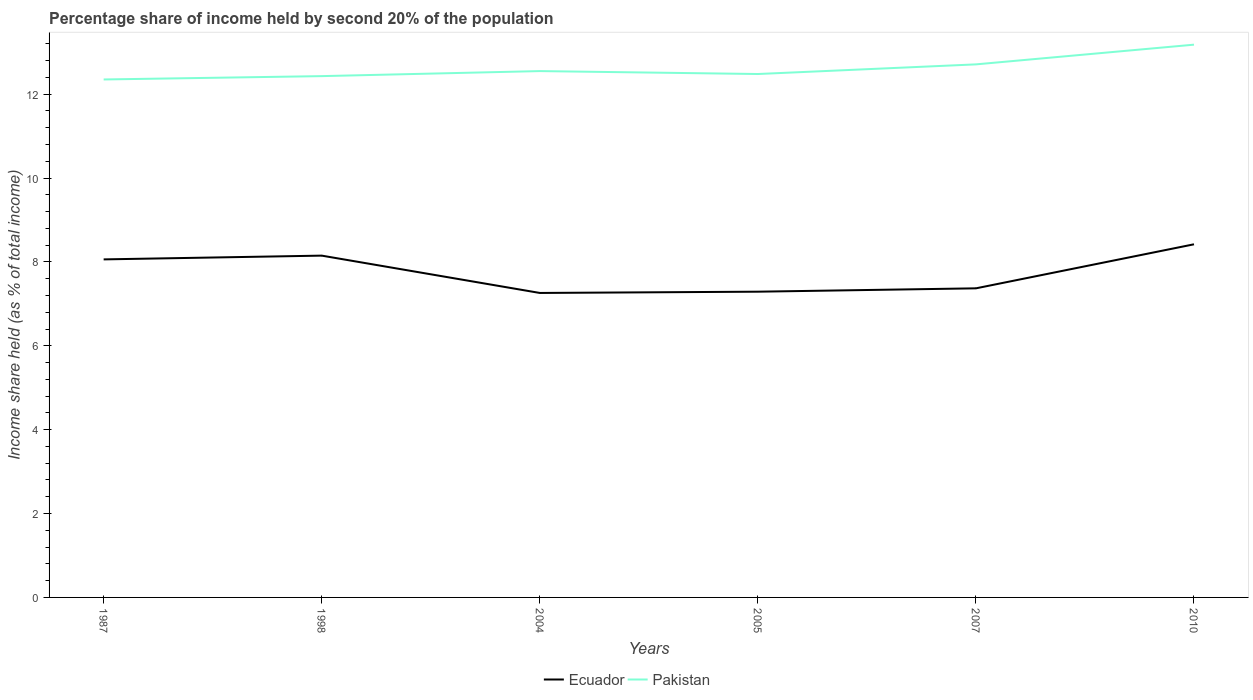Does the line corresponding to Ecuador intersect with the line corresponding to Pakistan?
Your response must be concise. No. Across all years, what is the maximum share of income held by second 20% of the population in Pakistan?
Offer a terse response. 12.35. In which year was the share of income held by second 20% of the population in Pakistan maximum?
Your answer should be very brief. 1987. What is the total share of income held by second 20% of the population in Pakistan in the graph?
Give a very brief answer. -0.16. What is the difference between the highest and the second highest share of income held by second 20% of the population in Pakistan?
Give a very brief answer. 0.83. What is the difference between the highest and the lowest share of income held by second 20% of the population in Pakistan?
Ensure brevity in your answer.  2. How many lines are there?
Provide a succinct answer. 2. What is the difference between two consecutive major ticks on the Y-axis?
Offer a terse response. 2. Does the graph contain any zero values?
Make the answer very short. No. Does the graph contain grids?
Your response must be concise. No. Where does the legend appear in the graph?
Your response must be concise. Bottom center. How many legend labels are there?
Offer a terse response. 2. What is the title of the graph?
Offer a terse response. Percentage share of income held by second 20% of the population. Does "Faeroe Islands" appear as one of the legend labels in the graph?
Offer a very short reply. No. What is the label or title of the Y-axis?
Offer a very short reply. Income share held (as % of total income). What is the Income share held (as % of total income) in Ecuador in 1987?
Keep it short and to the point. 8.06. What is the Income share held (as % of total income) in Pakistan in 1987?
Your answer should be compact. 12.35. What is the Income share held (as % of total income) in Ecuador in 1998?
Your response must be concise. 8.15. What is the Income share held (as % of total income) in Pakistan in 1998?
Your answer should be compact. 12.43. What is the Income share held (as % of total income) in Ecuador in 2004?
Offer a very short reply. 7.26. What is the Income share held (as % of total income) in Pakistan in 2004?
Give a very brief answer. 12.55. What is the Income share held (as % of total income) of Ecuador in 2005?
Your answer should be very brief. 7.29. What is the Income share held (as % of total income) of Pakistan in 2005?
Give a very brief answer. 12.48. What is the Income share held (as % of total income) in Ecuador in 2007?
Give a very brief answer. 7.37. What is the Income share held (as % of total income) of Pakistan in 2007?
Offer a very short reply. 12.71. What is the Income share held (as % of total income) in Ecuador in 2010?
Ensure brevity in your answer.  8.42. What is the Income share held (as % of total income) in Pakistan in 2010?
Your answer should be very brief. 13.18. Across all years, what is the maximum Income share held (as % of total income) of Ecuador?
Provide a short and direct response. 8.42. Across all years, what is the maximum Income share held (as % of total income) of Pakistan?
Your response must be concise. 13.18. Across all years, what is the minimum Income share held (as % of total income) in Ecuador?
Offer a terse response. 7.26. Across all years, what is the minimum Income share held (as % of total income) in Pakistan?
Provide a short and direct response. 12.35. What is the total Income share held (as % of total income) in Ecuador in the graph?
Your answer should be compact. 46.55. What is the total Income share held (as % of total income) of Pakistan in the graph?
Provide a short and direct response. 75.7. What is the difference between the Income share held (as % of total income) in Ecuador in 1987 and that in 1998?
Ensure brevity in your answer.  -0.09. What is the difference between the Income share held (as % of total income) of Pakistan in 1987 and that in 1998?
Offer a terse response. -0.08. What is the difference between the Income share held (as % of total income) of Ecuador in 1987 and that in 2005?
Make the answer very short. 0.77. What is the difference between the Income share held (as % of total income) of Pakistan in 1987 and that in 2005?
Give a very brief answer. -0.13. What is the difference between the Income share held (as % of total income) in Ecuador in 1987 and that in 2007?
Your response must be concise. 0.69. What is the difference between the Income share held (as % of total income) of Pakistan in 1987 and that in 2007?
Keep it short and to the point. -0.36. What is the difference between the Income share held (as % of total income) in Ecuador in 1987 and that in 2010?
Provide a succinct answer. -0.36. What is the difference between the Income share held (as % of total income) in Pakistan in 1987 and that in 2010?
Your answer should be compact. -0.83. What is the difference between the Income share held (as % of total income) in Ecuador in 1998 and that in 2004?
Offer a very short reply. 0.89. What is the difference between the Income share held (as % of total income) in Pakistan in 1998 and that in 2004?
Your answer should be compact. -0.12. What is the difference between the Income share held (as % of total income) in Ecuador in 1998 and that in 2005?
Your answer should be very brief. 0.86. What is the difference between the Income share held (as % of total income) in Ecuador in 1998 and that in 2007?
Provide a short and direct response. 0.78. What is the difference between the Income share held (as % of total income) of Pakistan in 1998 and that in 2007?
Your answer should be very brief. -0.28. What is the difference between the Income share held (as % of total income) in Ecuador in 1998 and that in 2010?
Your answer should be compact. -0.27. What is the difference between the Income share held (as % of total income) in Pakistan in 1998 and that in 2010?
Give a very brief answer. -0.75. What is the difference between the Income share held (as % of total income) in Ecuador in 2004 and that in 2005?
Provide a short and direct response. -0.03. What is the difference between the Income share held (as % of total income) of Pakistan in 2004 and that in 2005?
Your answer should be very brief. 0.07. What is the difference between the Income share held (as % of total income) in Ecuador in 2004 and that in 2007?
Give a very brief answer. -0.11. What is the difference between the Income share held (as % of total income) of Pakistan in 2004 and that in 2007?
Give a very brief answer. -0.16. What is the difference between the Income share held (as % of total income) in Ecuador in 2004 and that in 2010?
Your answer should be very brief. -1.16. What is the difference between the Income share held (as % of total income) of Pakistan in 2004 and that in 2010?
Provide a succinct answer. -0.63. What is the difference between the Income share held (as % of total income) of Ecuador in 2005 and that in 2007?
Your answer should be very brief. -0.08. What is the difference between the Income share held (as % of total income) of Pakistan in 2005 and that in 2007?
Make the answer very short. -0.23. What is the difference between the Income share held (as % of total income) of Ecuador in 2005 and that in 2010?
Provide a short and direct response. -1.13. What is the difference between the Income share held (as % of total income) in Pakistan in 2005 and that in 2010?
Provide a succinct answer. -0.7. What is the difference between the Income share held (as % of total income) in Ecuador in 2007 and that in 2010?
Provide a short and direct response. -1.05. What is the difference between the Income share held (as % of total income) of Pakistan in 2007 and that in 2010?
Give a very brief answer. -0.47. What is the difference between the Income share held (as % of total income) of Ecuador in 1987 and the Income share held (as % of total income) of Pakistan in 1998?
Your answer should be very brief. -4.37. What is the difference between the Income share held (as % of total income) of Ecuador in 1987 and the Income share held (as % of total income) of Pakistan in 2004?
Your response must be concise. -4.49. What is the difference between the Income share held (as % of total income) of Ecuador in 1987 and the Income share held (as % of total income) of Pakistan in 2005?
Provide a short and direct response. -4.42. What is the difference between the Income share held (as % of total income) in Ecuador in 1987 and the Income share held (as % of total income) in Pakistan in 2007?
Offer a very short reply. -4.65. What is the difference between the Income share held (as % of total income) of Ecuador in 1987 and the Income share held (as % of total income) of Pakistan in 2010?
Your answer should be very brief. -5.12. What is the difference between the Income share held (as % of total income) of Ecuador in 1998 and the Income share held (as % of total income) of Pakistan in 2005?
Your answer should be very brief. -4.33. What is the difference between the Income share held (as % of total income) in Ecuador in 1998 and the Income share held (as % of total income) in Pakistan in 2007?
Your answer should be very brief. -4.56. What is the difference between the Income share held (as % of total income) in Ecuador in 1998 and the Income share held (as % of total income) in Pakistan in 2010?
Your answer should be compact. -5.03. What is the difference between the Income share held (as % of total income) of Ecuador in 2004 and the Income share held (as % of total income) of Pakistan in 2005?
Offer a very short reply. -5.22. What is the difference between the Income share held (as % of total income) of Ecuador in 2004 and the Income share held (as % of total income) of Pakistan in 2007?
Provide a succinct answer. -5.45. What is the difference between the Income share held (as % of total income) in Ecuador in 2004 and the Income share held (as % of total income) in Pakistan in 2010?
Offer a very short reply. -5.92. What is the difference between the Income share held (as % of total income) of Ecuador in 2005 and the Income share held (as % of total income) of Pakistan in 2007?
Your answer should be compact. -5.42. What is the difference between the Income share held (as % of total income) in Ecuador in 2005 and the Income share held (as % of total income) in Pakistan in 2010?
Offer a terse response. -5.89. What is the difference between the Income share held (as % of total income) of Ecuador in 2007 and the Income share held (as % of total income) of Pakistan in 2010?
Offer a very short reply. -5.81. What is the average Income share held (as % of total income) in Ecuador per year?
Keep it short and to the point. 7.76. What is the average Income share held (as % of total income) of Pakistan per year?
Your answer should be compact. 12.62. In the year 1987, what is the difference between the Income share held (as % of total income) of Ecuador and Income share held (as % of total income) of Pakistan?
Your answer should be compact. -4.29. In the year 1998, what is the difference between the Income share held (as % of total income) in Ecuador and Income share held (as % of total income) in Pakistan?
Make the answer very short. -4.28. In the year 2004, what is the difference between the Income share held (as % of total income) in Ecuador and Income share held (as % of total income) in Pakistan?
Provide a short and direct response. -5.29. In the year 2005, what is the difference between the Income share held (as % of total income) in Ecuador and Income share held (as % of total income) in Pakistan?
Keep it short and to the point. -5.19. In the year 2007, what is the difference between the Income share held (as % of total income) of Ecuador and Income share held (as % of total income) of Pakistan?
Offer a very short reply. -5.34. In the year 2010, what is the difference between the Income share held (as % of total income) of Ecuador and Income share held (as % of total income) of Pakistan?
Make the answer very short. -4.76. What is the ratio of the Income share held (as % of total income) in Ecuador in 1987 to that in 2004?
Keep it short and to the point. 1.11. What is the ratio of the Income share held (as % of total income) of Pakistan in 1987 to that in 2004?
Make the answer very short. 0.98. What is the ratio of the Income share held (as % of total income) in Ecuador in 1987 to that in 2005?
Your answer should be compact. 1.11. What is the ratio of the Income share held (as % of total income) in Ecuador in 1987 to that in 2007?
Offer a very short reply. 1.09. What is the ratio of the Income share held (as % of total income) in Pakistan in 1987 to that in 2007?
Your response must be concise. 0.97. What is the ratio of the Income share held (as % of total income) of Ecuador in 1987 to that in 2010?
Your response must be concise. 0.96. What is the ratio of the Income share held (as % of total income) of Pakistan in 1987 to that in 2010?
Provide a short and direct response. 0.94. What is the ratio of the Income share held (as % of total income) in Ecuador in 1998 to that in 2004?
Provide a succinct answer. 1.12. What is the ratio of the Income share held (as % of total income) of Ecuador in 1998 to that in 2005?
Your response must be concise. 1.12. What is the ratio of the Income share held (as % of total income) of Ecuador in 1998 to that in 2007?
Offer a terse response. 1.11. What is the ratio of the Income share held (as % of total income) of Pakistan in 1998 to that in 2007?
Provide a short and direct response. 0.98. What is the ratio of the Income share held (as % of total income) of Ecuador in 1998 to that in 2010?
Your response must be concise. 0.97. What is the ratio of the Income share held (as % of total income) in Pakistan in 1998 to that in 2010?
Offer a terse response. 0.94. What is the ratio of the Income share held (as % of total income) in Ecuador in 2004 to that in 2005?
Offer a very short reply. 1. What is the ratio of the Income share held (as % of total income) in Pakistan in 2004 to that in 2005?
Keep it short and to the point. 1.01. What is the ratio of the Income share held (as % of total income) in Ecuador in 2004 to that in 2007?
Ensure brevity in your answer.  0.99. What is the ratio of the Income share held (as % of total income) of Pakistan in 2004 to that in 2007?
Your answer should be very brief. 0.99. What is the ratio of the Income share held (as % of total income) of Ecuador in 2004 to that in 2010?
Provide a succinct answer. 0.86. What is the ratio of the Income share held (as % of total income) in Pakistan in 2004 to that in 2010?
Make the answer very short. 0.95. What is the ratio of the Income share held (as % of total income) in Pakistan in 2005 to that in 2007?
Offer a very short reply. 0.98. What is the ratio of the Income share held (as % of total income) of Ecuador in 2005 to that in 2010?
Provide a succinct answer. 0.87. What is the ratio of the Income share held (as % of total income) of Pakistan in 2005 to that in 2010?
Your answer should be very brief. 0.95. What is the ratio of the Income share held (as % of total income) of Ecuador in 2007 to that in 2010?
Provide a short and direct response. 0.88. What is the difference between the highest and the second highest Income share held (as % of total income) in Ecuador?
Offer a very short reply. 0.27. What is the difference between the highest and the second highest Income share held (as % of total income) of Pakistan?
Ensure brevity in your answer.  0.47. What is the difference between the highest and the lowest Income share held (as % of total income) in Ecuador?
Your answer should be very brief. 1.16. What is the difference between the highest and the lowest Income share held (as % of total income) in Pakistan?
Ensure brevity in your answer.  0.83. 